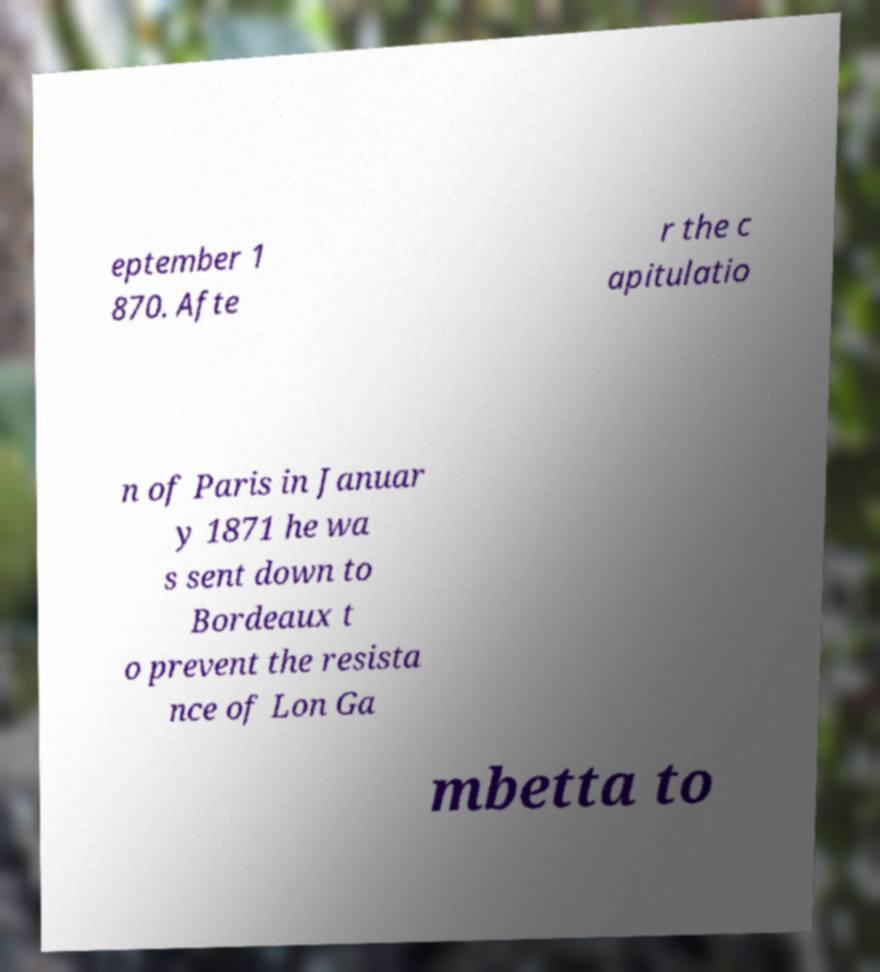Please identify and transcribe the text found in this image. eptember 1 870. Afte r the c apitulatio n of Paris in Januar y 1871 he wa s sent down to Bordeaux t o prevent the resista nce of Lon Ga mbetta to 